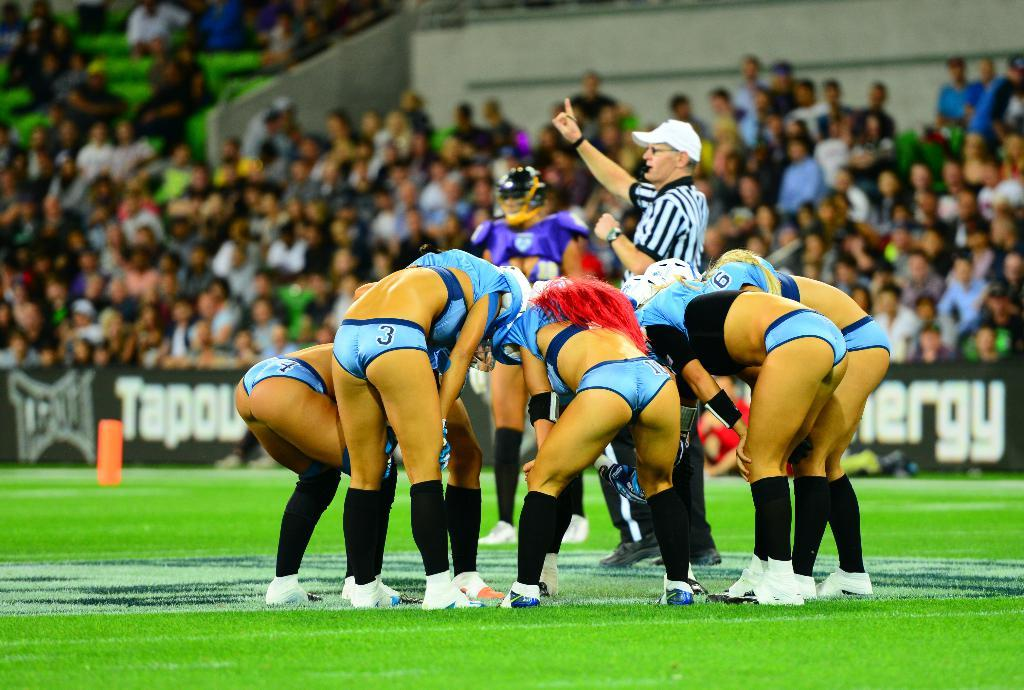What type of structure is shown in the image? There is a stadium in the image. What can be seen hanging or displayed in the image? There are banners in the image. What type of surface is visible in the image? There is grass visible in the image. What type of seed is being planted in the image? There is no seed being planted in the image; it features a stadium and banners. 